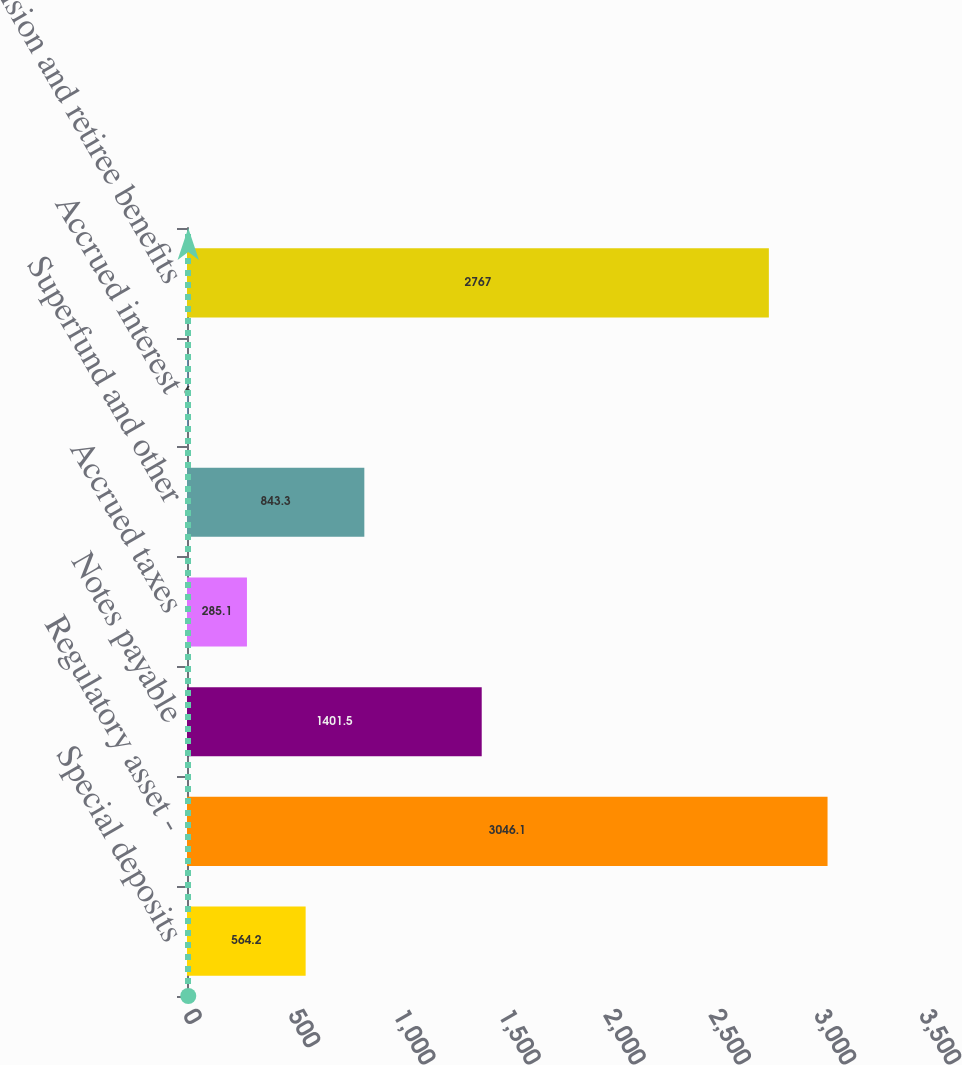<chart> <loc_0><loc_0><loc_500><loc_500><bar_chart><fcel>Special deposits<fcel>Regulatory asset -<fcel>Notes payable<fcel>Accrued taxes<fcel>Superfund and other<fcel>Accrued interest<fcel>Pension and retiree benefits<nl><fcel>564.2<fcel>3046.1<fcel>1401.5<fcel>285.1<fcel>843.3<fcel>6<fcel>2767<nl></chart> 